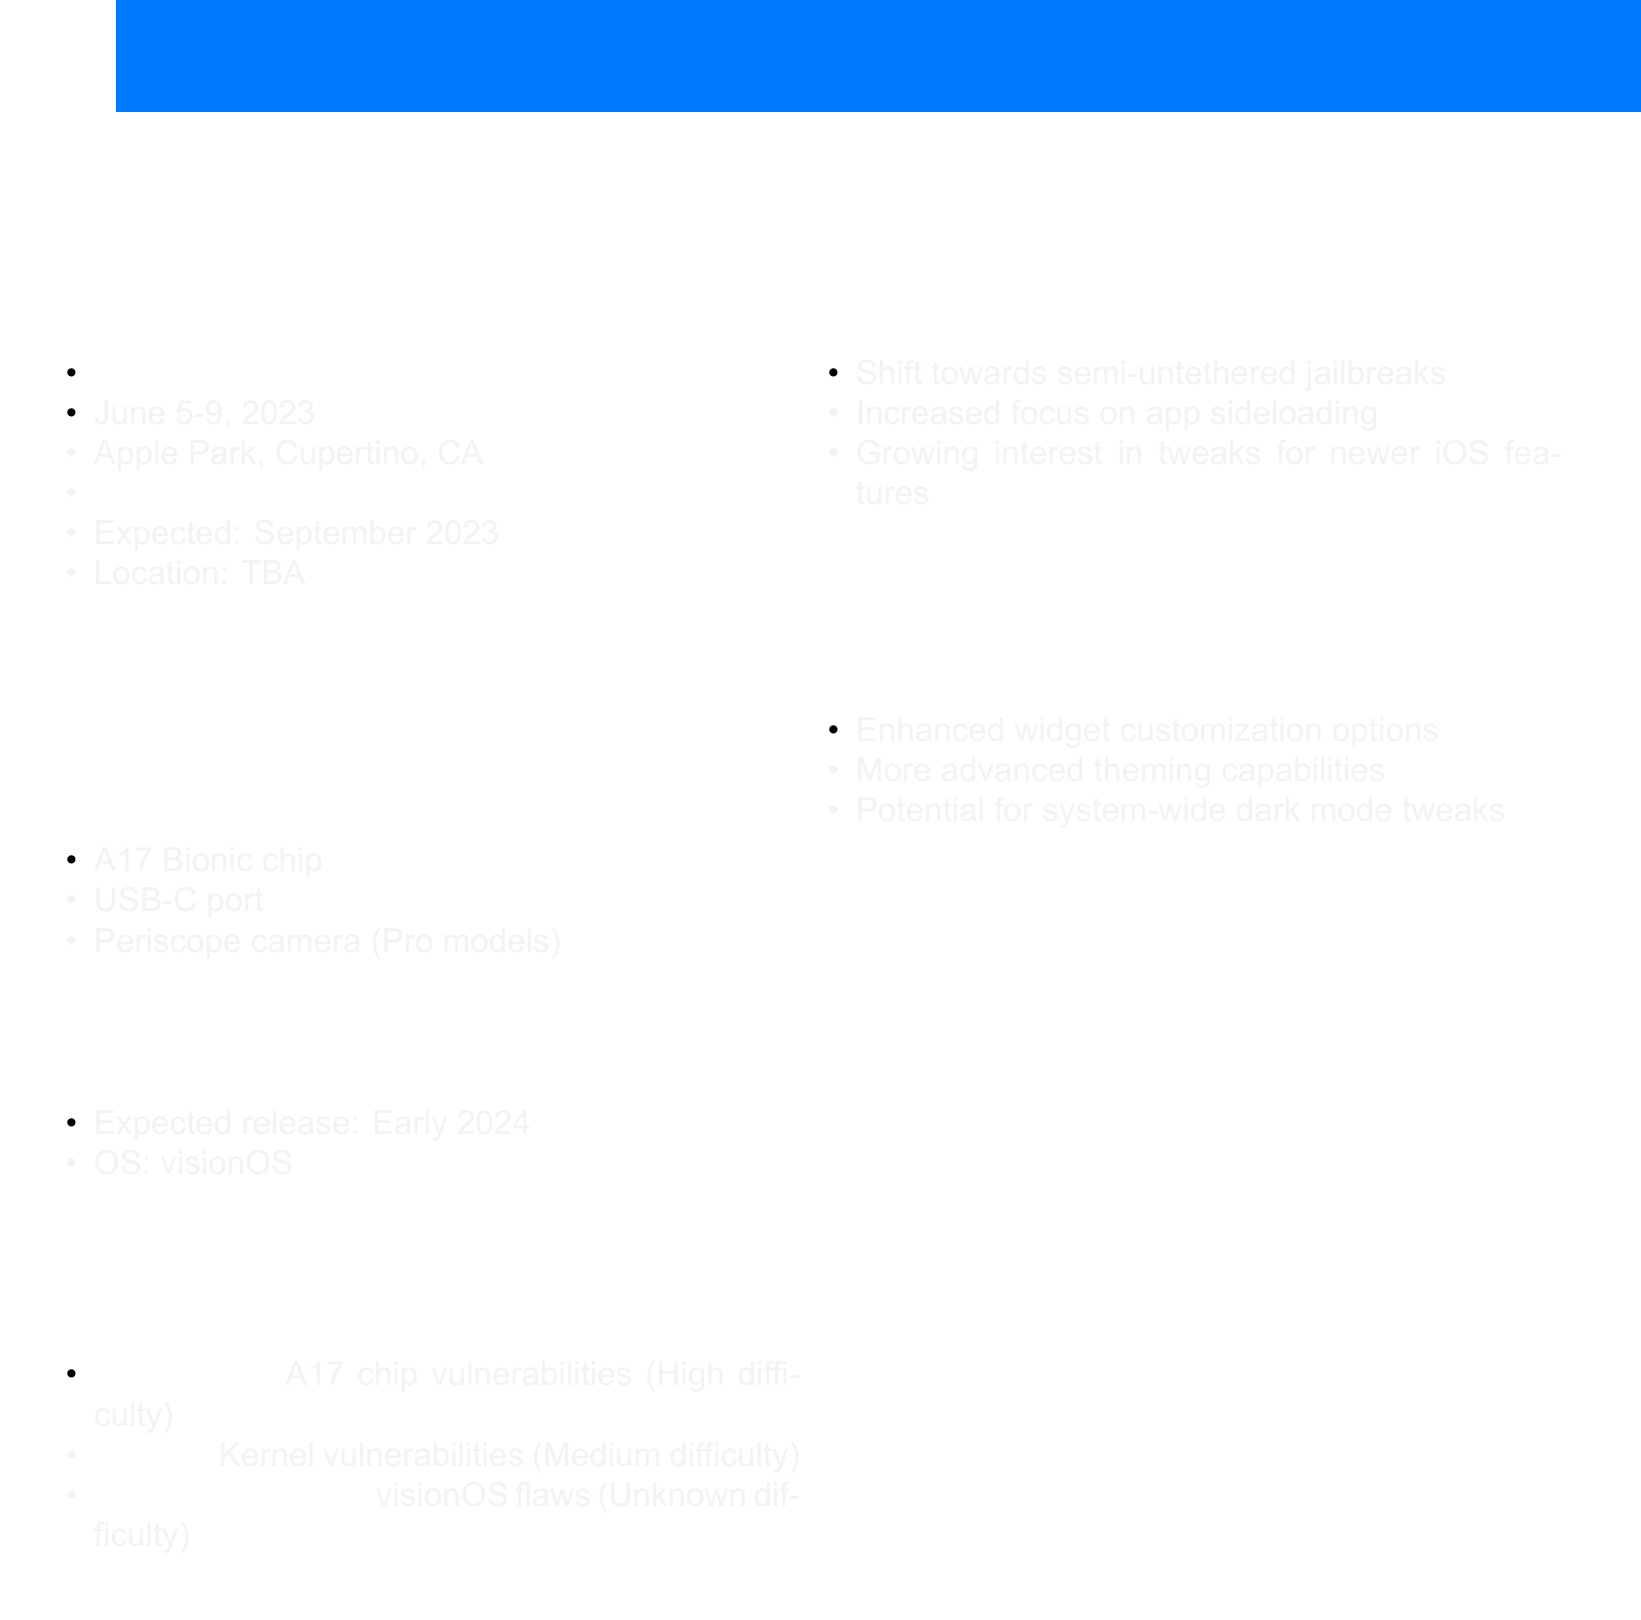what is the date of Apple WWDC 2023? The document states the event will be held from June 5-9, 2023.
Answer: June 5-9, 2023 where will the iPhone 15 Launch Event take place? The location for the iPhone 15 Launch Event is marked as TBA (To Be Announced).
Answer: TBA what is one expected feature of the iPhone 15 Series? The document lists several features, one of which is the A17 Bionic chip.
Answer: A17 Bionic chip what is the expected release date of Apple Vision Pro? The anticipated release date in the document is noted as Early 2024.
Answer: Early 2024 what is the difficulty level of jailbreaking the iPhone 15? The document indicates the difficulty level for jailbreaking the iPhone 15 based on vulnerabilities.
Answer: High how many anticipated products are listed? The document provides details on two anticipated products: iPhone 15 Series and Apple Vision Pro.
Answer: 2 which jailbreak opportunity has an unknown difficulty? The document specifies that the jailbreak opportunity related to the Apple Vision Pro has an unknown difficulty.
Answer: Apple Vision Pro what trend mentions increased focus on app sideloading? The document lists a trend related to jailbreaking that mentions an increased focus on app sideloading.
Answer: Increased focus on app sideloading what type of jailbreak is trending according to the document? The document refers to a shift towards semi-untethered jailbreaks as a current trend.
Answer: Semi-untethered jailbreaks 